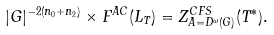<formula> <loc_0><loc_0><loc_500><loc_500>| G | ^ { - 2 ( n _ { 0 } + n _ { 2 } ) } \times F ^ { A C } ( L _ { T } ) = Z ^ { C F S } _ { A = D ^ { \omega } ( G ) } ( T ^ { \ast } ) .</formula> 